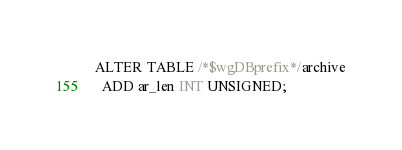<code> <loc_0><loc_0><loc_500><loc_500><_SQL_>ALTER TABLE /*$wgDBprefix*/archive
  ADD ar_len INT UNSIGNED;
</code> 